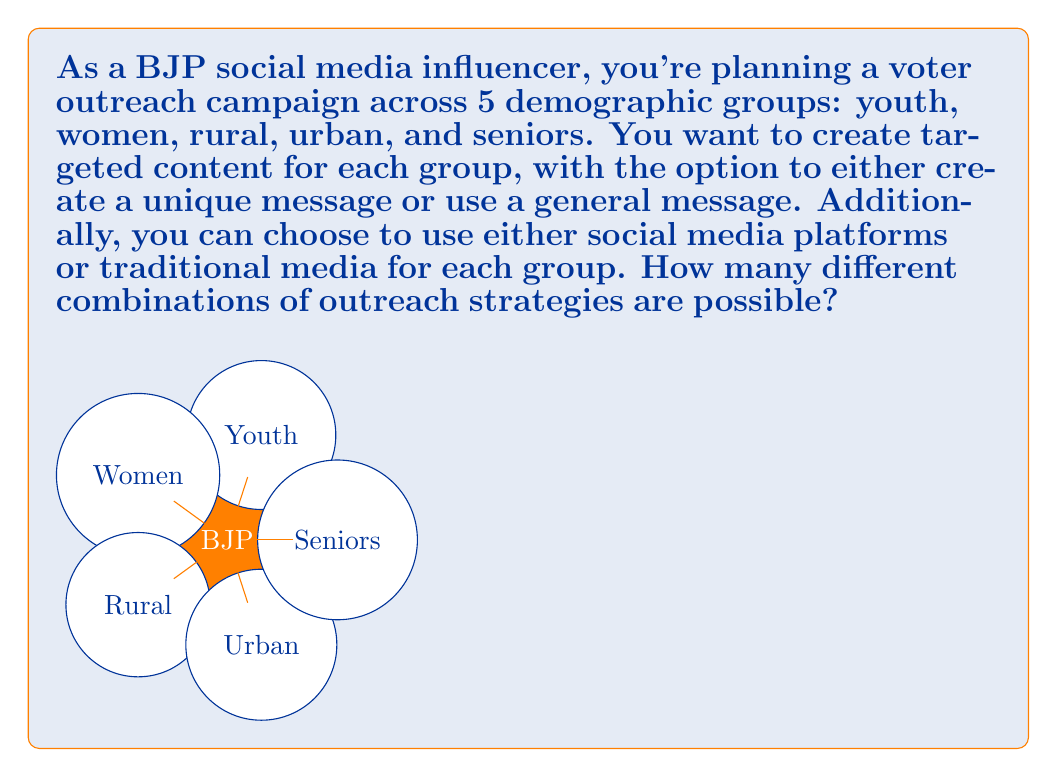What is the answer to this math problem? Let's approach this step-by-step:

1) For each demographic group, we have two choices to make:
   a) Message type: unique or general (2 options)
   b) Media type: social media or traditional media (2 options)

2) This means for each group, we have $2 \times 2 = 4$ possible combinations.

3) We need to make these choices for all 5 demographic groups independently.

4) When we have independent choices, we multiply the number of options for each choice.

5) Therefore, the total number of combinations is:

   $$ 4^5 = 4 \times 4 \times 4 \times 4 \times 4 = 1024 $$

6) We can also express this using exponents:

   $$ (2 \times 2)^5 = 2^5 \times 2^5 = 32 \times 32 = 1024 $$

This means there are 1024 different ways to combine message types and media choices across the five demographic groups in the BJP voter outreach campaign.
Answer: 1024 